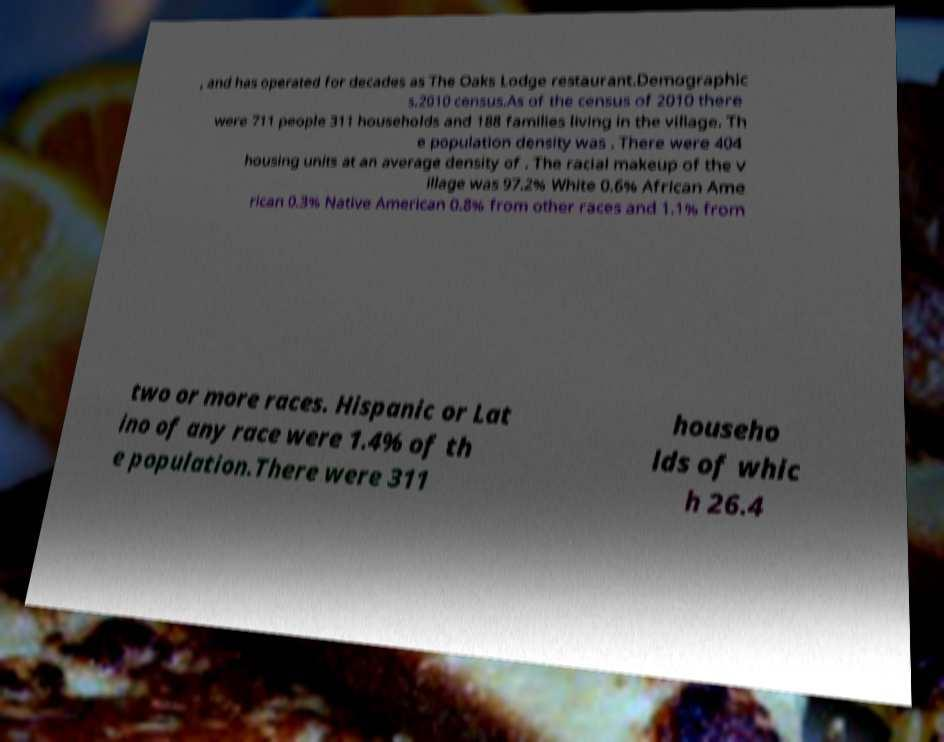For documentation purposes, I need the text within this image transcribed. Could you provide that? , and has operated for decades as The Oaks Lodge restaurant.Demographic s.2010 census.As of the census of 2010 there were 711 people 311 households and 188 families living in the village. Th e population density was . There were 404 housing units at an average density of . The racial makeup of the v illage was 97.2% White 0.6% African Ame rican 0.3% Native American 0.8% from other races and 1.1% from two or more races. Hispanic or Lat ino of any race were 1.4% of th e population.There were 311 househo lds of whic h 26.4 